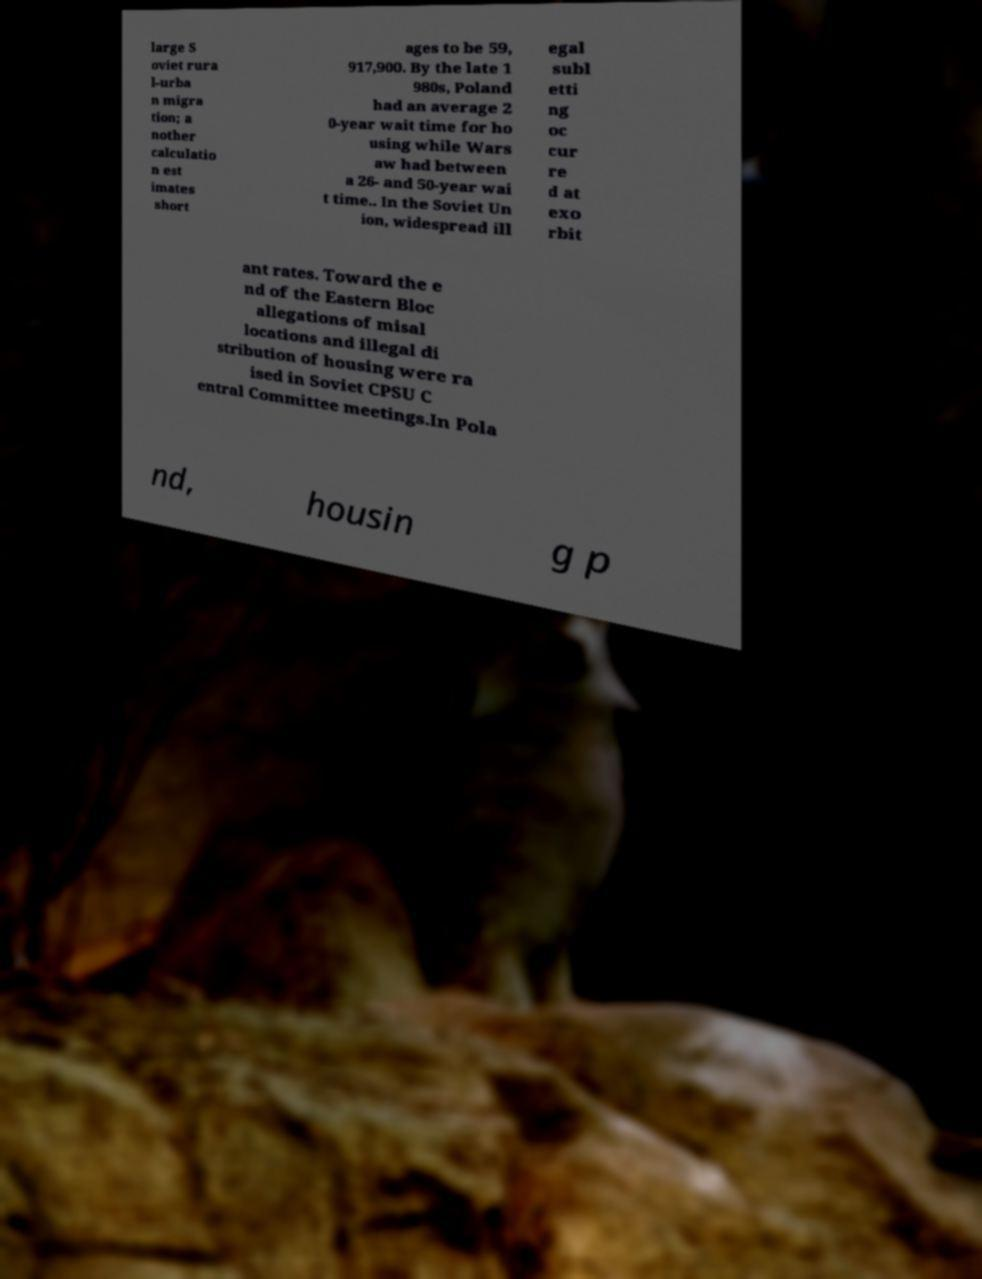For documentation purposes, I need the text within this image transcribed. Could you provide that? large S oviet rura l-urba n migra tion; a nother calculatio n est imates short ages to be 59, 917,900. By the late 1 980s, Poland had an average 2 0-year wait time for ho using while Wars aw had between a 26- and 50-year wai t time.. In the Soviet Un ion, widespread ill egal subl etti ng oc cur re d at exo rbit ant rates. Toward the e nd of the Eastern Bloc allegations of misal locations and illegal di stribution of housing were ra ised in Soviet CPSU C entral Committee meetings.In Pola nd, housin g p 